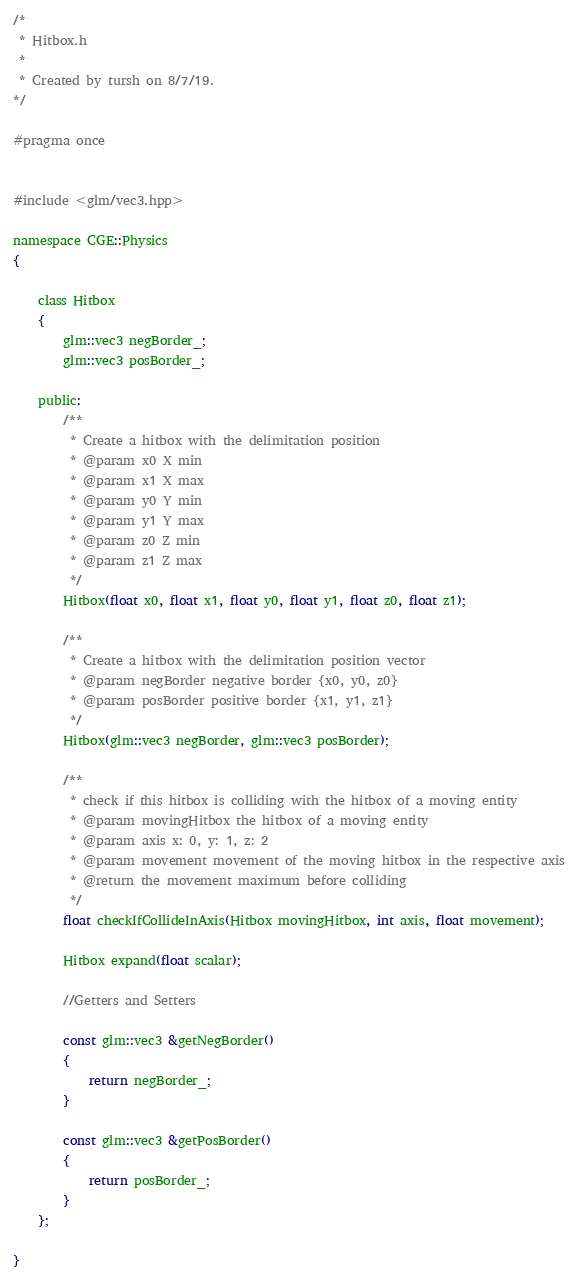Convert code to text. <code><loc_0><loc_0><loc_500><loc_500><_C_>/*
 * Hitbox.h
 *
 * Created by tursh on 8/7/19.
*/

#pragma once


#include <glm/vec3.hpp>

namespace CGE::Physics
{

    class Hitbox
    {
        glm::vec3 negBorder_;
        glm::vec3 posBorder_;

    public:
        /**
         * Create a hitbox with the delimitation position
         * @param x0 X min
         * @param x1 X max
         * @param y0 Y min
         * @param y1 Y max
         * @param z0 Z min
         * @param z1 Z max
         */
        Hitbox(float x0, float x1, float y0, float y1, float z0, float z1);

        /**
         * Create a hitbox with the delimitation position vector
         * @param negBorder negative border {x0, y0, z0}
         * @param posBorder positive border {x1, y1, z1}
         */
        Hitbox(glm::vec3 negBorder, glm::vec3 posBorder);

        /**
         * check if this hitbox is colliding with the hitbox of a moving entity
         * @param movingHitbox the hitbox of a moving entity
         * @param axis x: 0, y: 1, z: 2
         * @param movement movement of the moving hitbox in the respective axis
         * @return the movement maximum before colliding
         */
        float checkIfCollideInAxis(Hitbox movingHitbox, int axis, float movement);

        Hitbox expand(float scalar);

        //Getters and Setters

        const glm::vec3 &getNegBorder()
        {
            return negBorder_;
        }

        const glm::vec3 &getPosBorder()
        {
            return posBorder_;
        }
    };

}</code> 